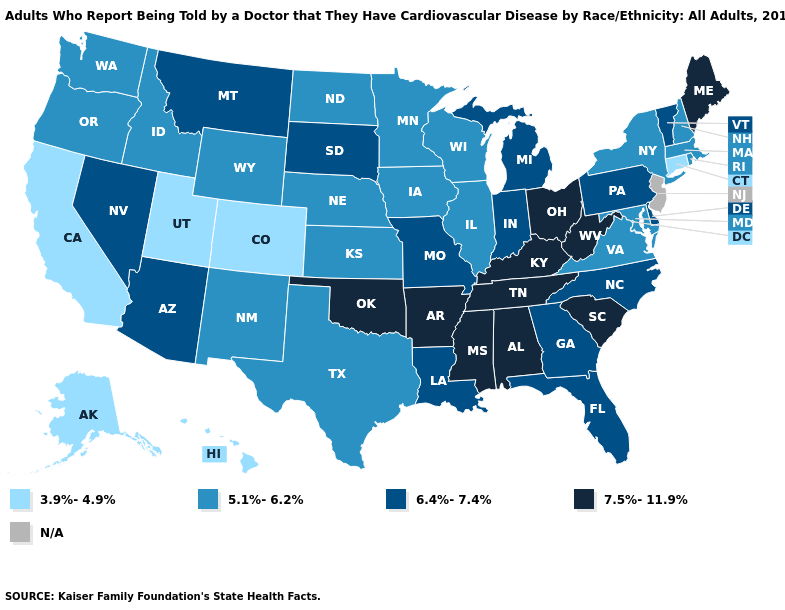Does the map have missing data?
Quick response, please. Yes. Name the states that have a value in the range 5.1%-6.2%?
Write a very short answer. Idaho, Illinois, Iowa, Kansas, Maryland, Massachusetts, Minnesota, Nebraska, New Hampshire, New Mexico, New York, North Dakota, Oregon, Rhode Island, Texas, Virginia, Washington, Wisconsin, Wyoming. Does the map have missing data?
Be succinct. Yes. Which states have the highest value in the USA?
Write a very short answer. Alabama, Arkansas, Kentucky, Maine, Mississippi, Ohio, Oklahoma, South Carolina, Tennessee, West Virginia. Among the states that border Minnesota , which have the highest value?
Short answer required. South Dakota. Name the states that have a value in the range 5.1%-6.2%?
Keep it brief. Idaho, Illinois, Iowa, Kansas, Maryland, Massachusetts, Minnesota, Nebraska, New Hampshire, New Mexico, New York, North Dakota, Oregon, Rhode Island, Texas, Virginia, Washington, Wisconsin, Wyoming. What is the value of New York?
Quick response, please. 5.1%-6.2%. What is the value of North Carolina?
Answer briefly. 6.4%-7.4%. Among the states that border Oklahoma , which have the highest value?
Write a very short answer. Arkansas. Name the states that have a value in the range 7.5%-11.9%?
Concise answer only. Alabama, Arkansas, Kentucky, Maine, Mississippi, Ohio, Oklahoma, South Carolina, Tennessee, West Virginia. Does Ohio have the highest value in the MidWest?
Concise answer only. Yes. Among the states that border Tennessee , which have the highest value?
Keep it brief. Alabama, Arkansas, Kentucky, Mississippi. 